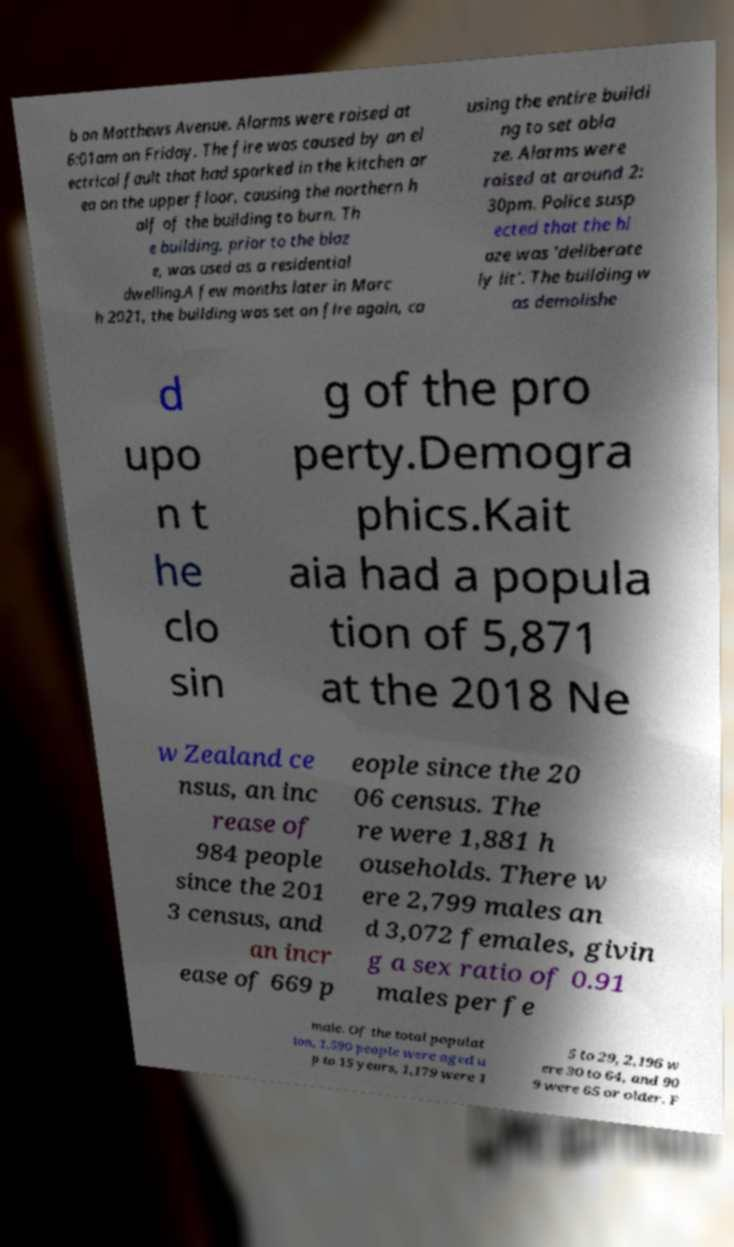Could you assist in decoding the text presented in this image and type it out clearly? b on Matthews Avenue. Alarms were raised at 6:01am on Friday. The fire was caused by an el ectrical fault that had sparked in the kitchen ar ea on the upper floor, causing the northern h alf of the building to burn. Th e building, prior to the blaz e, was used as a residential dwelling.A few months later in Marc h 2021, the building was set on fire again, ca using the entire buildi ng to set abla ze. Alarms were raised at around 2: 30pm. Police susp ected that the bl aze was 'deliberate ly lit'. The building w as demolishe d upo n t he clo sin g of the pro perty.Demogra phics.Kait aia had a popula tion of 5,871 at the 2018 Ne w Zealand ce nsus, an inc rease of 984 people since the 201 3 census, and an incr ease of 669 p eople since the 20 06 census. The re were 1,881 h ouseholds. There w ere 2,799 males an d 3,072 females, givin g a sex ratio of 0.91 males per fe male. Of the total populat ion, 1,590 people were aged u p to 15 years, 1,179 were 1 5 to 29, 2,196 w ere 30 to 64, and 90 9 were 65 or older. F 